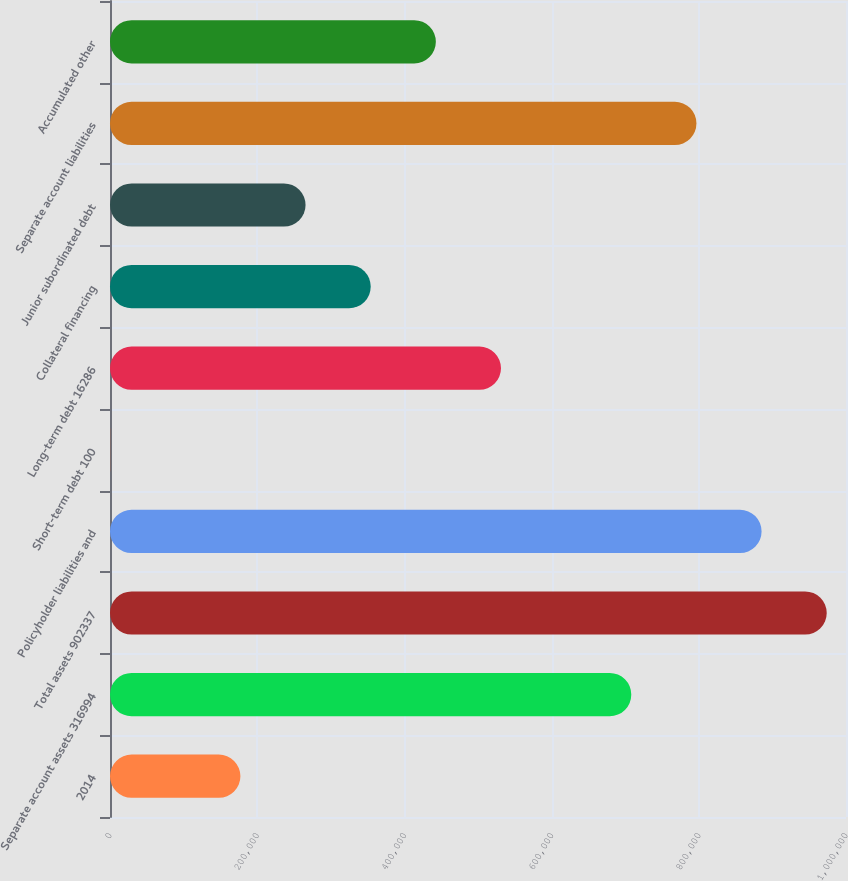<chart> <loc_0><loc_0><loc_500><loc_500><bar_chart><fcel>2014<fcel>Separate account assets 316994<fcel>Total assets 902337<fcel>Policyholder liabilities and<fcel>Short-term debt 100<fcel>Long-term debt 16286<fcel>Collateral financing<fcel>Junior subordinated debt<fcel>Separate account liabilities<fcel>Accumulated other<nl><fcel>177199<fcel>708272<fcel>973808<fcel>885296<fcel>175<fcel>531248<fcel>354223<fcel>265711<fcel>796784<fcel>442736<nl></chart> 